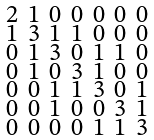<formula> <loc_0><loc_0><loc_500><loc_500>\begin{smallmatrix} 2 & 1 & 0 & 0 & 0 & 0 & 0 \\ 1 & 3 & 1 & 1 & 0 & 0 & 0 \\ 0 & 1 & 3 & 0 & 1 & 1 & 0 \\ 0 & 1 & 0 & 3 & 1 & 0 & 0 \\ 0 & 0 & 1 & 1 & 3 & 0 & 1 \\ 0 & 0 & 1 & 0 & 0 & 3 & 1 \\ 0 & 0 & 0 & 0 & 1 & 1 & 3 \end{smallmatrix}</formula> 